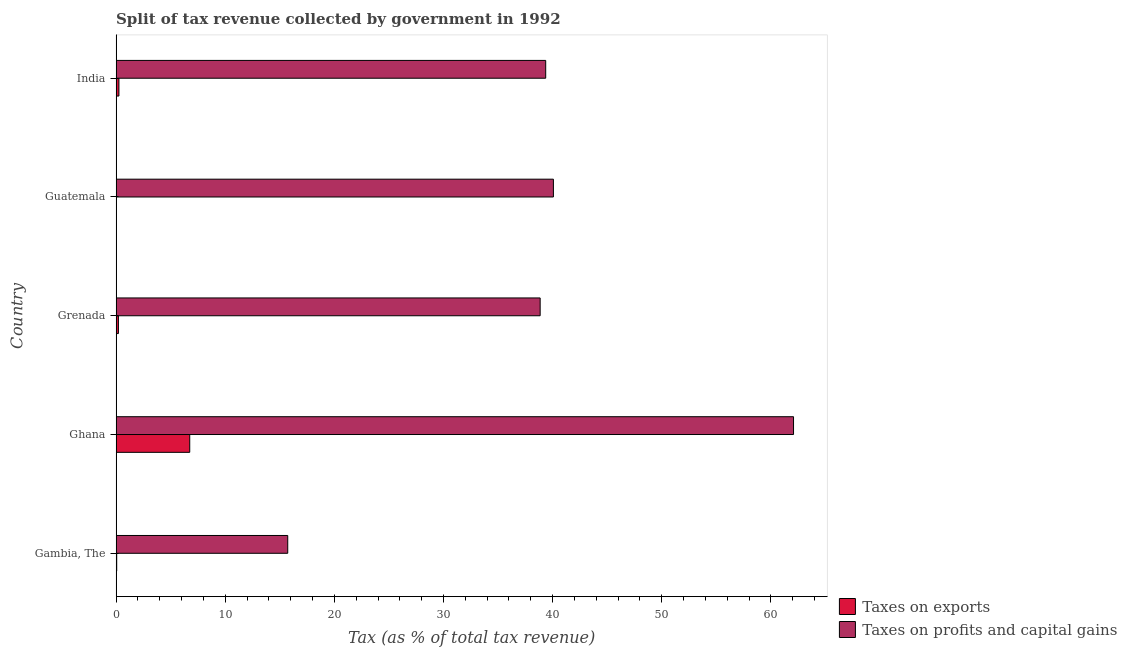How many bars are there on the 4th tick from the top?
Offer a terse response. 2. How many bars are there on the 4th tick from the bottom?
Offer a very short reply. 2. What is the label of the 2nd group of bars from the top?
Provide a succinct answer. Guatemala. In how many cases, is the number of bars for a given country not equal to the number of legend labels?
Keep it short and to the point. 0. What is the percentage of revenue obtained from taxes on profits and capital gains in Grenada?
Offer a terse response. 38.86. Across all countries, what is the maximum percentage of revenue obtained from taxes on exports?
Provide a succinct answer. 6.75. Across all countries, what is the minimum percentage of revenue obtained from taxes on profits and capital gains?
Your answer should be compact. 15.73. In which country was the percentage of revenue obtained from taxes on profits and capital gains maximum?
Ensure brevity in your answer.  Ghana. In which country was the percentage of revenue obtained from taxes on exports minimum?
Offer a terse response. Guatemala. What is the total percentage of revenue obtained from taxes on profits and capital gains in the graph?
Provide a succinct answer. 196.1. What is the difference between the percentage of revenue obtained from taxes on exports in Ghana and that in India?
Make the answer very short. 6.49. What is the difference between the percentage of revenue obtained from taxes on exports in Grenada and the percentage of revenue obtained from taxes on profits and capital gains in Gambia, The?
Your answer should be compact. -15.52. What is the average percentage of revenue obtained from taxes on profits and capital gains per country?
Offer a terse response. 39.22. What is the difference between the percentage of revenue obtained from taxes on profits and capital gains and percentage of revenue obtained from taxes on exports in Gambia, The?
Provide a short and direct response. 15.67. What is the ratio of the percentage of revenue obtained from taxes on profits and capital gains in Gambia, The to that in Ghana?
Your answer should be compact. 0.25. Is the percentage of revenue obtained from taxes on exports in Guatemala less than that in India?
Your answer should be very brief. Yes. Is the difference between the percentage of revenue obtained from taxes on exports in Ghana and Guatemala greater than the difference between the percentage of revenue obtained from taxes on profits and capital gains in Ghana and Guatemala?
Provide a succinct answer. No. What is the difference between the highest and the second highest percentage of revenue obtained from taxes on exports?
Give a very brief answer. 6.49. What is the difference between the highest and the lowest percentage of revenue obtained from taxes on exports?
Keep it short and to the point. 6.73. Is the sum of the percentage of revenue obtained from taxes on profits and capital gains in Gambia, The and Ghana greater than the maximum percentage of revenue obtained from taxes on exports across all countries?
Your answer should be very brief. Yes. What does the 1st bar from the top in India represents?
Your answer should be compact. Taxes on profits and capital gains. What does the 2nd bar from the bottom in Grenada represents?
Provide a succinct answer. Taxes on profits and capital gains. How many countries are there in the graph?
Provide a succinct answer. 5. What is the difference between two consecutive major ticks on the X-axis?
Provide a short and direct response. 10. Are the values on the major ticks of X-axis written in scientific E-notation?
Your answer should be compact. No. Does the graph contain grids?
Keep it short and to the point. No. How many legend labels are there?
Offer a very short reply. 2. How are the legend labels stacked?
Ensure brevity in your answer.  Vertical. What is the title of the graph?
Make the answer very short. Split of tax revenue collected by government in 1992. What is the label or title of the X-axis?
Offer a very short reply. Tax (as % of total tax revenue). What is the Tax (as % of total tax revenue) in Taxes on exports in Gambia, The?
Your answer should be very brief. 0.05. What is the Tax (as % of total tax revenue) in Taxes on profits and capital gains in Gambia, The?
Your response must be concise. 15.73. What is the Tax (as % of total tax revenue) in Taxes on exports in Ghana?
Provide a succinct answer. 6.75. What is the Tax (as % of total tax revenue) of Taxes on profits and capital gains in Ghana?
Your response must be concise. 62.08. What is the Tax (as % of total tax revenue) of Taxes on exports in Grenada?
Your answer should be compact. 0.21. What is the Tax (as % of total tax revenue) of Taxes on profits and capital gains in Grenada?
Your answer should be very brief. 38.86. What is the Tax (as % of total tax revenue) in Taxes on exports in Guatemala?
Your answer should be very brief. 0.02. What is the Tax (as % of total tax revenue) of Taxes on profits and capital gains in Guatemala?
Ensure brevity in your answer.  40.07. What is the Tax (as % of total tax revenue) in Taxes on exports in India?
Offer a terse response. 0.26. What is the Tax (as % of total tax revenue) in Taxes on profits and capital gains in India?
Your response must be concise. 39.37. Across all countries, what is the maximum Tax (as % of total tax revenue) of Taxes on exports?
Give a very brief answer. 6.75. Across all countries, what is the maximum Tax (as % of total tax revenue) of Taxes on profits and capital gains?
Make the answer very short. 62.08. Across all countries, what is the minimum Tax (as % of total tax revenue) in Taxes on exports?
Provide a succinct answer. 0.02. Across all countries, what is the minimum Tax (as % of total tax revenue) of Taxes on profits and capital gains?
Keep it short and to the point. 15.73. What is the total Tax (as % of total tax revenue) in Taxes on exports in the graph?
Your answer should be very brief. 7.28. What is the total Tax (as % of total tax revenue) in Taxes on profits and capital gains in the graph?
Provide a succinct answer. 196.1. What is the difference between the Tax (as % of total tax revenue) in Taxes on exports in Gambia, The and that in Ghana?
Give a very brief answer. -6.69. What is the difference between the Tax (as % of total tax revenue) in Taxes on profits and capital gains in Gambia, The and that in Ghana?
Give a very brief answer. -46.35. What is the difference between the Tax (as % of total tax revenue) of Taxes on exports in Gambia, The and that in Grenada?
Make the answer very short. -0.16. What is the difference between the Tax (as % of total tax revenue) in Taxes on profits and capital gains in Gambia, The and that in Grenada?
Offer a terse response. -23.13. What is the difference between the Tax (as % of total tax revenue) of Taxes on exports in Gambia, The and that in Guatemala?
Your answer should be compact. 0.03. What is the difference between the Tax (as % of total tax revenue) in Taxes on profits and capital gains in Gambia, The and that in Guatemala?
Offer a terse response. -24.35. What is the difference between the Tax (as % of total tax revenue) in Taxes on exports in Gambia, The and that in India?
Your response must be concise. -0.2. What is the difference between the Tax (as % of total tax revenue) in Taxes on profits and capital gains in Gambia, The and that in India?
Your answer should be very brief. -23.64. What is the difference between the Tax (as % of total tax revenue) in Taxes on exports in Ghana and that in Grenada?
Ensure brevity in your answer.  6.53. What is the difference between the Tax (as % of total tax revenue) in Taxes on profits and capital gains in Ghana and that in Grenada?
Keep it short and to the point. 23.22. What is the difference between the Tax (as % of total tax revenue) of Taxes on exports in Ghana and that in Guatemala?
Your answer should be very brief. 6.73. What is the difference between the Tax (as % of total tax revenue) of Taxes on profits and capital gains in Ghana and that in Guatemala?
Offer a terse response. 22.01. What is the difference between the Tax (as % of total tax revenue) of Taxes on exports in Ghana and that in India?
Keep it short and to the point. 6.49. What is the difference between the Tax (as % of total tax revenue) in Taxes on profits and capital gains in Ghana and that in India?
Provide a short and direct response. 22.71. What is the difference between the Tax (as % of total tax revenue) of Taxes on exports in Grenada and that in Guatemala?
Offer a very short reply. 0.19. What is the difference between the Tax (as % of total tax revenue) of Taxes on profits and capital gains in Grenada and that in Guatemala?
Offer a very short reply. -1.21. What is the difference between the Tax (as % of total tax revenue) of Taxes on exports in Grenada and that in India?
Provide a succinct answer. -0.05. What is the difference between the Tax (as % of total tax revenue) of Taxes on profits and capital gains in Grenada and that in India?
Your response must be concise. -0.51. What is the difference between the Tax (as % of total tax revenue) in Taxes on exports in Guatemala and that in India?
Keep it short and to the point. -0.24. What is the difference between the Tax (as % of total tax revenue) in Taxes on profits and capital gains in Guatemala and that in India?
Provide a succinct answer. 0.71. What is the difference between the Tax (as % of total tax revenue) in Taxes on exports in Gambia, The and the Tax (as % of total tax revenue) in Taxes on profits and capital gains in Ghana?
Provide a succinct answer. -62.03. What is the difference between the Tax (as % of total tax revenue) in Taxes on exports in Gambia, The and the Tax (as % of total tax revenue) in Taxes on profits and capital gains in Grenada?
Offer a terse response. -38.81. What is the difference between the Tax (as % of total tax revenue) of Taxes on exports in Gambia, The and the Tax (as % of total tax revenue) of Taxes on profits and capital gains in Guatemala?
Offer a terse response. -40.02. What is the difference between the Tax (as % of total tax revenue) in Taxes on exports in Gambia, The and the Tax (as % of total tax revenue) in Taxes on profits and capital gains in India?
Keep it short and to the point. -39.31. What is the difference between the Tax (as % of total tax revenue) of Taxes on exports in Ghana and the Tax (as % of total tax revenue) of Taxes on profits and capital gains in Grenada?
Give a very brief answer. -32.11. What is the difference between the Tax (as % of total tax revenue) of Taxes on exports in Ghana and the Tax (as % of total tax revenue) of Taxes on profits and capital gains in Guatemala?
Give a very brief answer. -33.33. What is the difference between the Tax (as % of total tax revenue) of Taxes on exports in Ghana and the Tax (as % of total tax revenue) of Taxes on profits and capital gains in India?
Keep it short and to the point. -32.62. What is the difference between the Tax (as % of total tax revenue) of Taxes on exports in Grenada and the Tax (as % of total tax revenue) of Taxes on profits and capital gains in Guatemala?
Ensure brevity in your answer.  -39.86. What is the difference between the Tax (as % of total tax revenue) in Taxes on exports in Grenada and the Tax (as % of total tax revenue) in Taxes on profits and capital gains in India?
Offer a very short reply. -39.16. What is the difference between the Tax (as % of total tax revenue) in Taxes on exports in Guatemala and the Tax (as % of total tax revenue) in Taxes on profits and capital gains in India?
Give a very brief answer. -39.35. What is the average Tax (as % of total tax revenue) of Taxes on exports per country?
Offer a very short reply. 1.46. What is the average Tax (as % of total tax revenue) in Taxes on profits and capital gains per country?
Your answer should be very brief. 39.22. What is the difference between the Tax (as % of total tax revenue) of Taxes on exports and Tax (as % of total tax revenue) of Taxes on profits and capital gains in Gambia, The?
Provide a short and direct response. -15.67. What is the difference between the Tax (as % of total tax revenue) of Taxes on exports and Tax (as % of total tax revenue) of Taxes on profits and capital gains in Ghana?
Provide a short and direct response. -55.33. What is the difference between the Tax (as % of total tax revenue) in Taxes on exports and Tax (as % of total tax revenue) in Taxes on profits and capital gains in Grenada?
Your answer should be very brief. -38.65. What is the difference between the Tax (as % of total tax revenue) in Taxes on exports and Tax (as % of total tax revenue) in Taxes on profits and capital gains in Guatemala?
Your answer should be very brief. -40.05. What is the difference between the Tax (as % of total tax revenue) of Taxes on exports and Tax (as % of total tax revenue) of Taxes on profits and capital gains in India?
Offer a terse response. -39.11. What is the ratio of the Tax (as % of total tax revenue) in Taxes on exports in Gambia, The to that in Ghana?
Offer a terse response. 0.01. What is the ratio of the Tax (as % of total tax revenue) in Taxes on profits and capital gains in Gambia, The to that in Ghana?
Ensure brevity in your answer.  0.25. What is the ratio of the Tax (as % of total tax revenue) of Taxes on exports in Gambia, The to that in Grenada?
Give a very brief answer. 0.25. What is the ratio of the Tax (as % of total tax revenue) in Taxes on profits and capital gains in Gambia, The to that in Grenada?
Offer a terse response. 0.4. What is the ratio of the Tax (as % of total tax revenue) in Taxes on exports in Gambia, The to that in Guatemala?
Provide a succinct answer. 2.69. What is the ratio of the Tax (as % of total tax revenue) of Taxes on profits and capital gains in Gambia, The to that in Guatemala?
Your answer should be very brief. 0.39. What is the ratio of the Tax (as % of total tax revenue) in Taxes on exports in Gambia, The to that in India?
Provide a short and direct response. 0.21. What is the ratio of the Tax (as % of total tax revenue) in Taxes on profits and capital gains in Gambia, The to that in India?
Ensure brevity in your answer.  0.4. What is the ratio of the Tax (as % of total tax revenue) in Taxes on exports in Ghana to that in Grenada?
Your answer should be compact. 32.01. What is the ratio of the Tax (as % of total tax revenue) in Taxes on profits and capital gains in Ghana to that in Grenada?
Your answer should be compact. 1.6. What is the ratio of the Tax (as % of total tax revenue) in Taxes on exports in Ghana to that in Guatemala?
Your answer should be very brief. 344.04. What is the ratio of the Tax (as % of total tax revenue) of Taxes on profits and capital gains in Ghana to that in Guatemala?
Provide a short and direct response. 1.55. What is the ratio of the Tax (as % of total tax revenue) of Taxes on exports in Ghana to that in India?
Provide a short and direct response. 26.36. What is the ratio of the Tax (as % of total tax revenue) in Taxes on profits and capital gains in Ghana to that in India?
Make the answer very short. 1.58. What is the ratio of the Tax (as % of total tax revenue) in Taxes on exports in Grenada to that in Guatemala?
Your response must be concise. 10.75. What is the ratio of the Tax (as % of total tax revenue) of Taxes on profits and capital gains in Grenada to that in Guatemala?
Your answer should be very brief. 0.97. What is the ratio of the Tax (as % of total tax revenue) of Taxes on exports in Grenada to that in India?
Offer a terse response. 0.82. What is the ratio of the Tax (as % of total tax revenue) in Taxes on profits and capital gains in Grenada to that in India?
Your answer should be compact. 0.99. What is the ratio of the Tax (as % of total tax revenue) of Taxes on exports in Guatemala to that in India?
Offer a very short reply. 0.08. What is the ratio of the Tax (as % of total tax revenue) of Taxes on profits and capital gains in Guatemala to that in India?
Keep it short and to the point. 1.02. What is the difference between the highest and the second highest Tax (as % of total tax revenue) of Taxes on exports?
Provide a succinct answer. 6.49. What is the difference between the highest and the second highest Tax (as % of total tax revenue) of Taxes on profits and capital gains?
Keep it short and to the point. 22.01. What is the difference between the highest and the lowest Tax (as % of total tax revenue) of Taxes on exports?
Your answer should be compact. 6.73. What is the difference between the highest and the lowest Tax (as % of total tax revenue) of Taxes on profits and capital gains?
Provide a short and direct response. 46.35. 